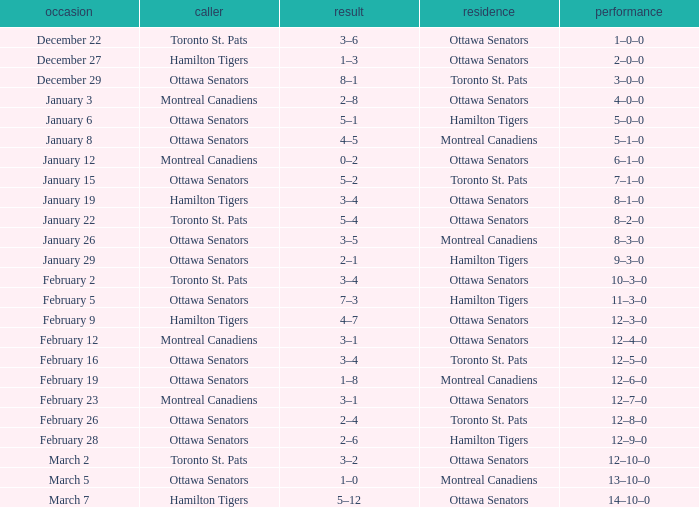What is the score of the game on January 12? 0–2. Could you parse the entire table? {'header': ['occasion', 'caller', 'result', 'residence', 'performance'], 'rows': [['December 22', 'Toronto St. Pats', '3–6', 'Ottawa Senators', '1–0–0'], ['December 27', 'Hamilton Tigers', '1–3', 'Ottawa Senators', '2–0–0'], ['December 29', 'Ottawa Senators', '8–1', 'Toronto St. Pats', '3–0–0'], ['January 3', 'Montreal Canadiens', '2–8', 'Ottawa Senators', '4–0–0'], ['January 6', 'Ottawa Senators', '5–1', 'Hamilton Tigers', '5–0–0'], ['January 8', 'Ottawa Senators', '4–5', 'Montreal Canadiens', '5–1–0'], ['January 12', 'Montreal Canadiens', '0–2', 'Ottawa Senators', '6–1–0'], ['January 15', 'Ottawa Senators', '5–2', 'Toronto St. Pats', '7–1–0'], ['January 19', 'Hamilton Tigers', '3–4', 'Ottawa Senators', '8–1–0'], ['January 22', 'Toronto St. Pats', '5–4', 'Ottawa Senators', '8–2–0'], ['January 26', 'Ottawa Senators', '3–5', 'Montreal Canadiens', '8–3–0'], ['January 29', 'Ottawa Senators', '2–1', 'Hamilton Tigers', '9–3–0'], ['February 2', 'Toronto St. Pats', '3–4', 'Ottawa Senators', '10–3–0'], ['February 5', 'Ottawa Senators', '7–3', 'Hamilton Tigers', '11–3–0'], ['February 9', 'Hamilton Tigers', '4–7', 'Ottawa Senators', '12–3–0'], ['February 12', 'Montreal Canadiens', '3–1', 'Ottawa Senators', '12–4–0'], ['February 16', 'Ottawa Senators', '3–4', 'Toronto St. Pats', '12–5–0'], ['February 19', 'Ottawa Senators', '1–8', 'Montreal Canadiens', '12–6–0'], ['February 23', 'Montreal Canadiens', '3–1', 'Ottawa Senators', '12–7–0'], ['February 26', 'Ottawa Senators', '2–4', 'Toronto St. Pats', '12–8–0'], ['February 28', 'Ottawa Senators', '2–6', 'Hamilton Tigers', '12–9–0'], ['March 2', 'Toronto St. Pats', '3–2', 'Ottawa Senators', '12–10–0'], ['March 5', 'Ottawa Senators', '1–0', 'Montreal Canadiens', '13–10–0'], ['March 7', 'Hamilton Tigers', '5–12', 'Ottawa Senators', '14–10–0']]} 